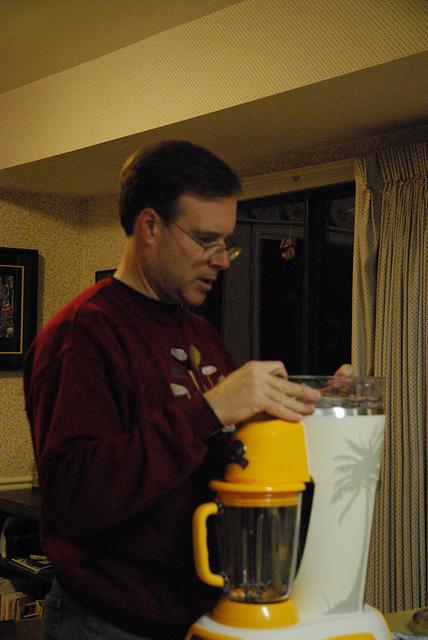What appliance is he using?
Quick response, please. Blender. Is it likely that he has a food handler's permit?
Quick response, please. No. What season was this photo most likely taken in?
Write a very short answer. Winter. What is on his face?
Quick response, please. Glasses. Is the man making a shake?
Be succinct. No. How many people?
Answer briefly. 1. What color is the plastic lid?
Be succinct. Yellow. 